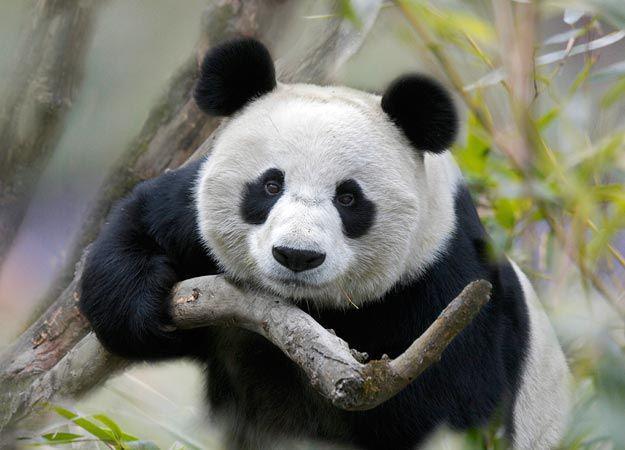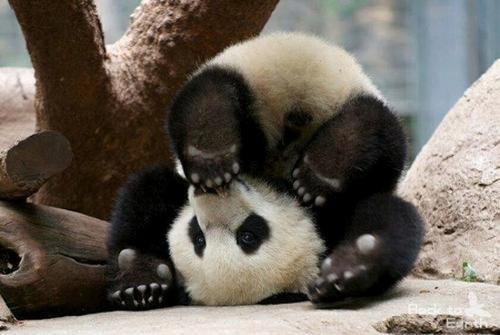The first image is the image on the left, the second image is the image on the right. For the images displayed, is the sentence "there are at most 2 pandas in the image pair" factually correct? Answer yes or no. Yes. The first image is the image on the left, the second image is the image on the right. For the images displayed, is the sentence "There are three pandas" factually correct? Answer yes or no. No. 